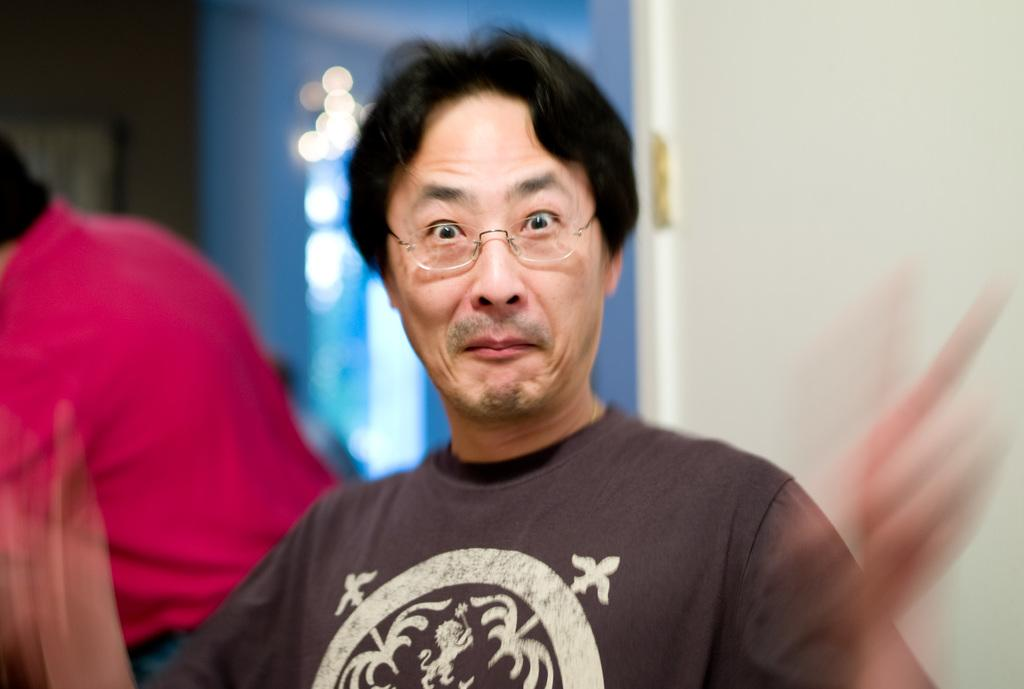What is the main subject of the image? There is a man standing in the image. Can you describe the man's appearance? The man is wearing glasses. What color is the background of the image? The background of the image is blue. Are there any other people visible in the image? Yes, there is at least one person visible in the background. What type of authority does the fireman have in the image? There is no fireman present in the image, so it is not possible to determine any authority they might have. 